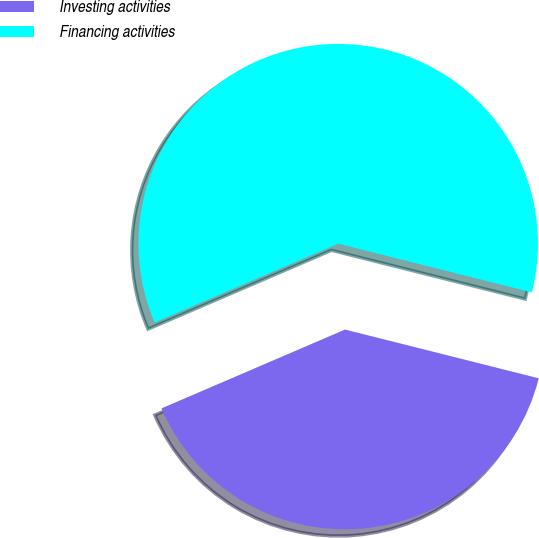Convert chart to OTSL. <chart><loc_0><loc_0><loc_500><loc_500><pie_chart><fcel>Investing activities<fcel>Financing activities<nl><fcel>39.62%<fcel>60.38%<nl></chart> 